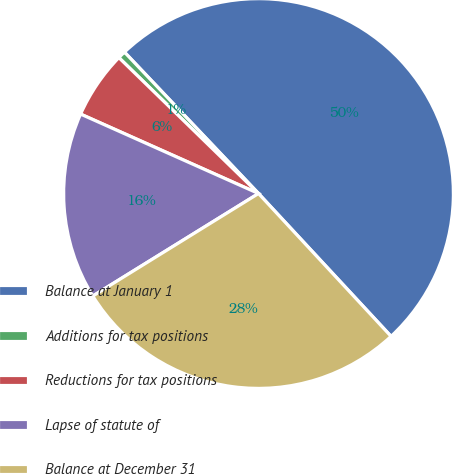<chart> <loc_0><loc_0><loc_500><loc_500><pie_chart><fcel>Balance at January 1<fcel>Additions for tax positions<fcel>Reductions for tax positions<fcel>Lapse of statute of<fcel>Balance at December 31<nl><fcel>50.17%<fcel>0.64%<fcel>5.6%<fcel>15.5%<fcel>28.09%<nl></chart> 